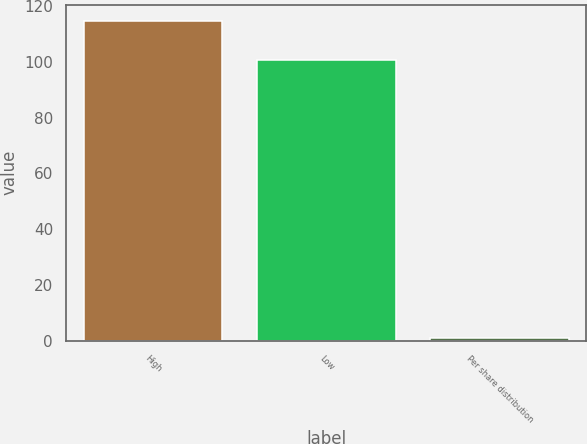<chart> <loc_0><loc_0><loc_500><loc_500><bar_chart><fcel>High<fcel>Low<fcel>Per share distribution<nl><fcel>114.67<fcel>100.53<fcel>0.8<nl></chart> 